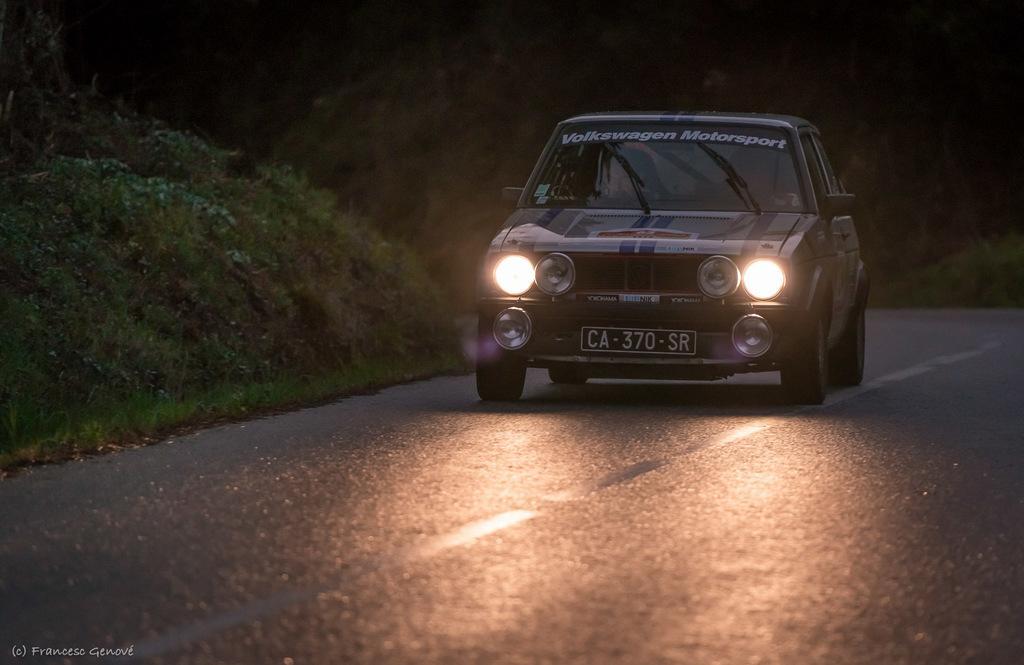Could you give a brief overview of what you see in this image? In this image we can see a vehicle with a number plate on the road, there is some grass and the background it is dark. 